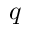Convert formula to latex. <formula><loc_0><loc_0><loc_500><loc_500>q</formula> 